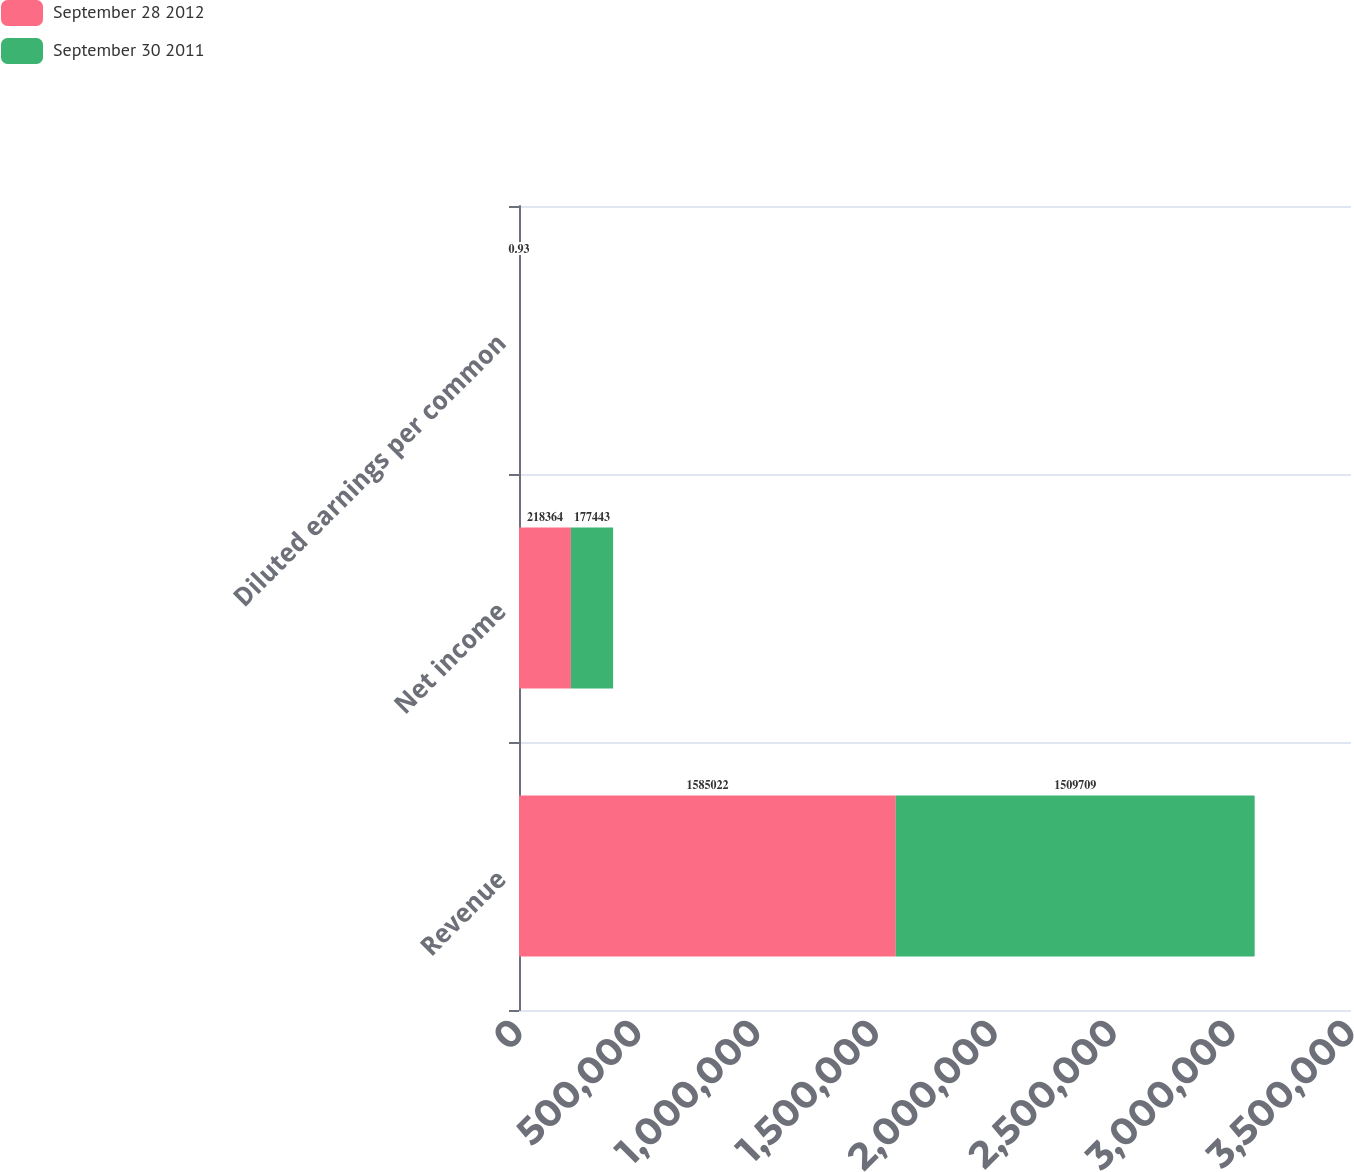Convert chart. <chart><loc_0><loc_0><loc_500><loc_500><stacked_bar_chart><ecel><fcel>Revenue<fcel>Net income<fcel>Diluted earnings per common<nl><fcel>September 28 2012<fcel>1.58502e+06<fcel>218364<fcel>1.14<nl><fcel>September 30 2011<fcel>1.50971e+06<fcel>177443<fcel>0.93<nl></chart> 